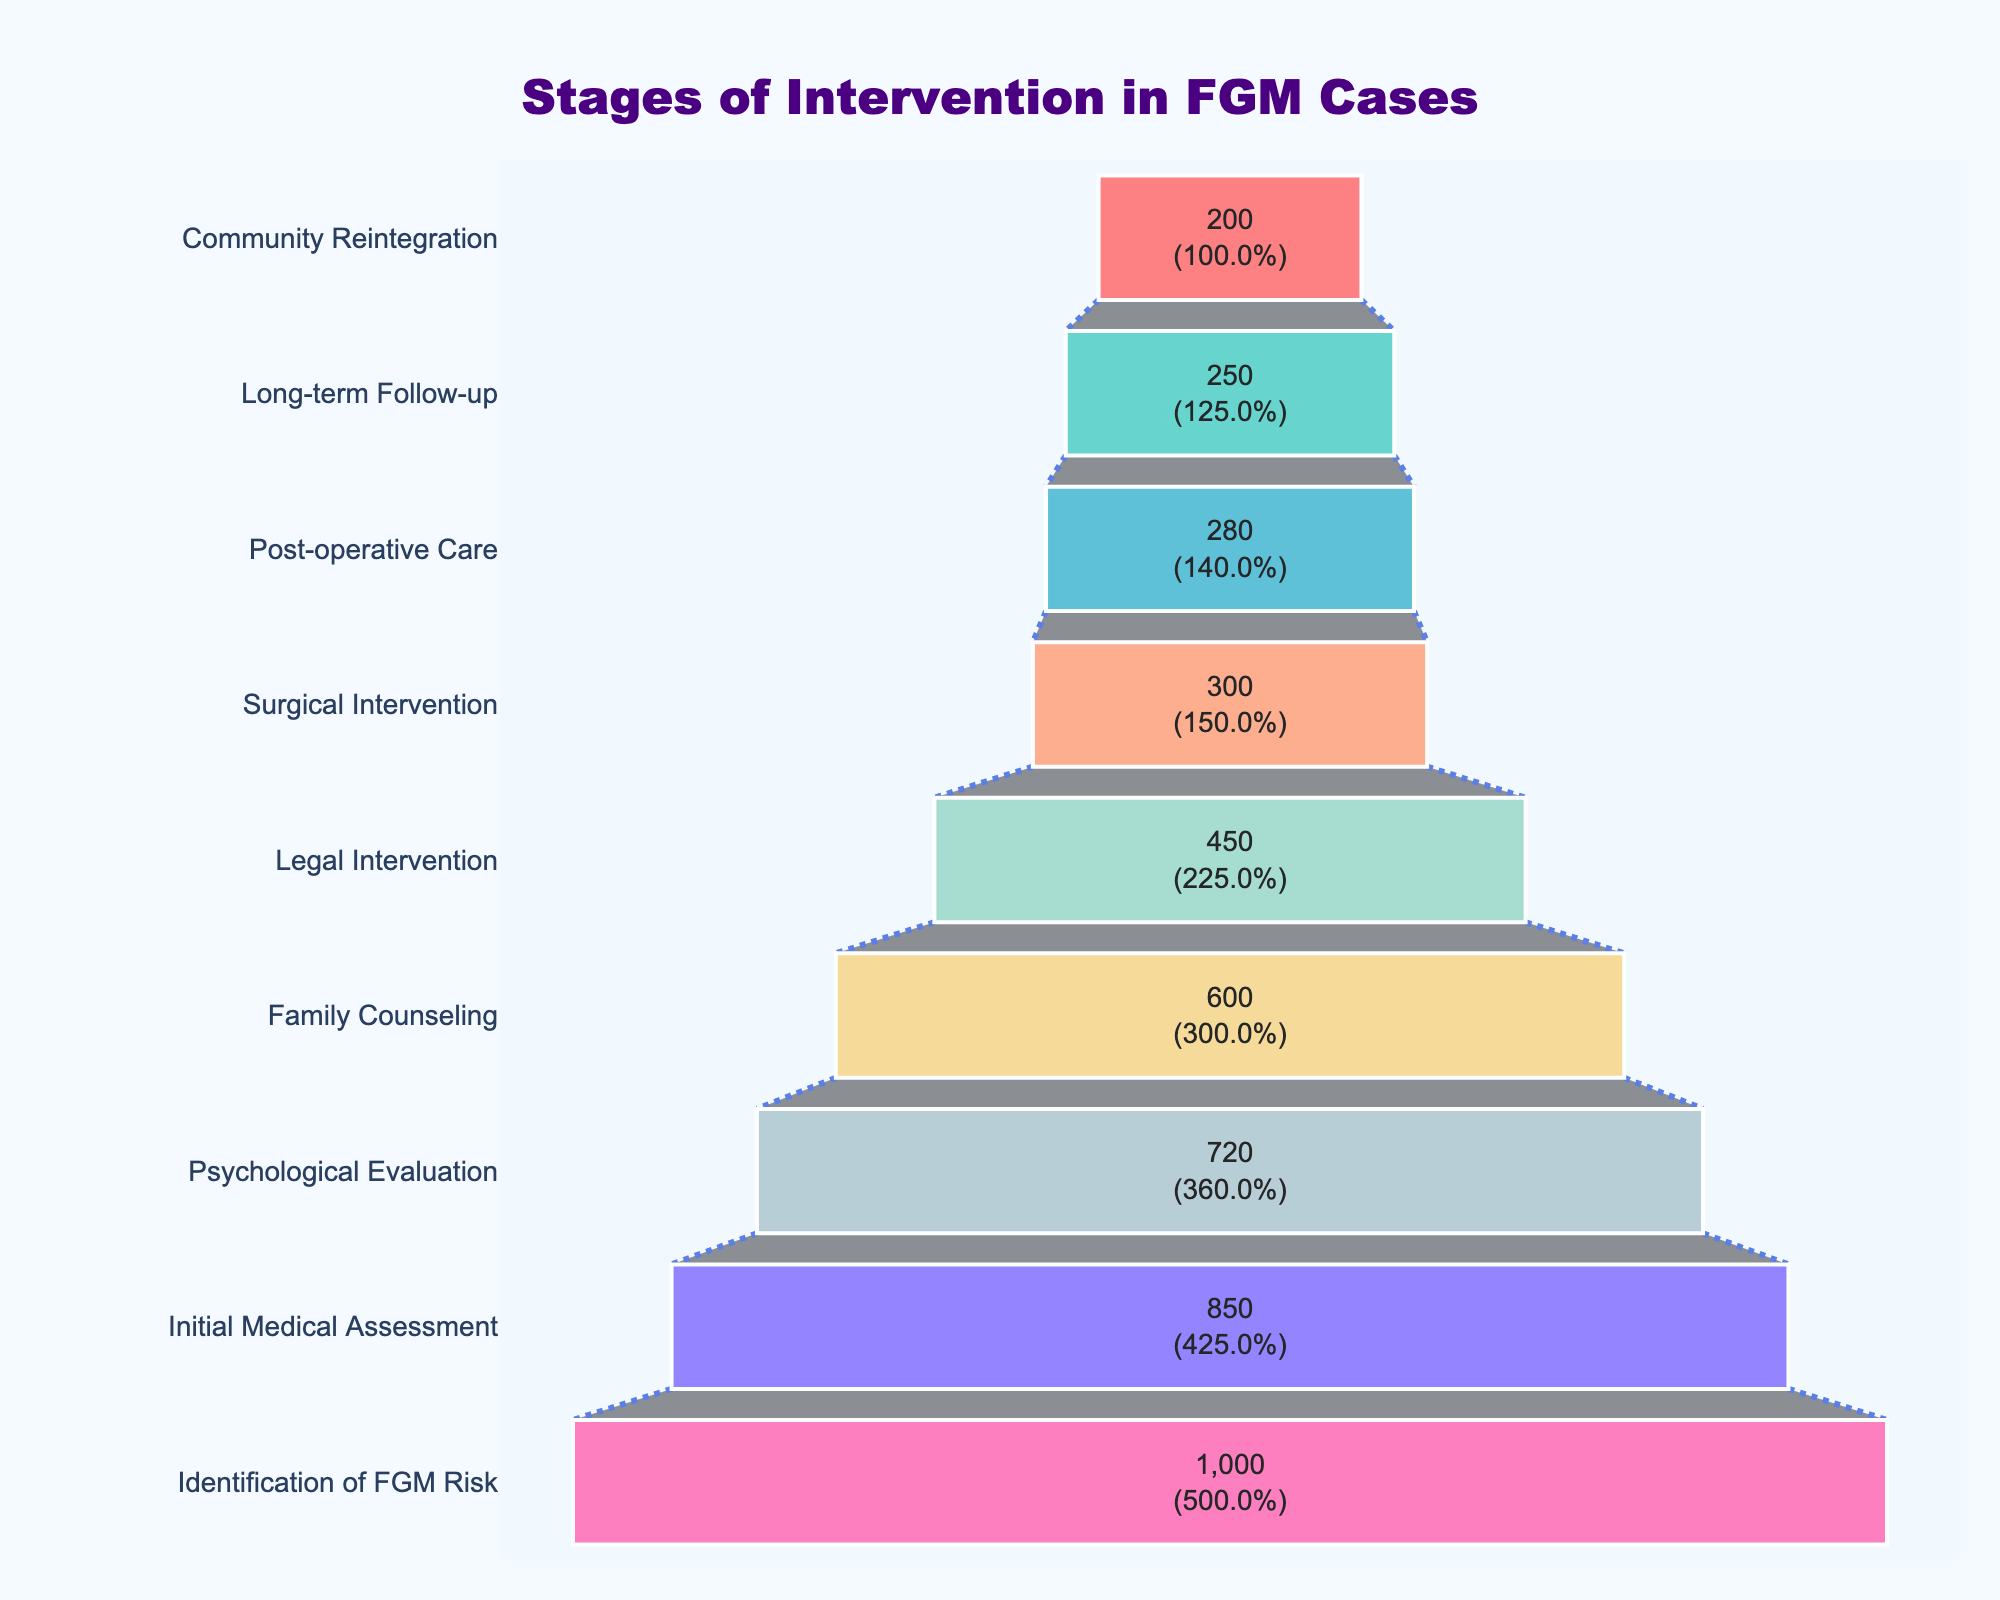How many stages are depicted in the funnel chart? Count the number of unique stages listed from top to bottom.
Answer: 9 What is the title of the funnel chart? Read the title text prominently displayed at the top of the chart.
Answer: Stages of Intervention in FGM Cases Which stage has the lowest number of cases? Identify the stage at the narrowest part of the funnel at the bottom.
Answer: Community Reintegration How many cases reach the Family Counseling stage? Locate "Family Counseling" on the y-axis and read its corresponding value.
Answer: 600 What percentage of cases identified for FGM risk progress to the Legal Intervention stage? Find the number of cases at the Legal Intervention stage (450) and divide by the initial number of cases (1000), then multiply by 100 to get the percentage: (450/1000) * 100.
Answer: 45% How many more cases are there in the Initial Medical Assessment stage than in the Psychological Evaluation stage? Subtract the number of cases in the Psychological Evaluation stage (720) from those in the Initial Medical Assessment stage (850). 850 - 720 = 130.
Answer: 130 What is the drop in the number of cases from Surgical Intervention to Post-operative Care? Subtract the number for Post-operative Care (280) from the number for Surgical Intervention (300). 300 - 280 = 20.
Answer: 20 Which stage shows the highest percentage decrease from the previous stage? Calculate the percentage decrease between subsequent stages and compare. For example, from Identification of FGM Risk to Initial Medical Assessment: (1000 - 850) / 1000 * 100 = 15%. Continue this pattern for each pair. The highest percentage drop is between Initial Medical Assessment (850) and Psychological Evaluation (720): (850 - 720) / 850 * 100 = 15.29%. The next highest is between Family Counseling (600) and Legal Intervention (450): (600 - 450) / 600 * 100 = 25%.
Answer: Family Counseling to Legal Intervention How many cases make it all the way through to Community Reintegration? Look at the number corresponding to Community Reintegration at the bottom of the funnel.
Answer: 200 What is the color used to represent the Psychological Evaluation stage? Observe the bar color corresponding to the Psychological Evaluation stage on the y-axis.
Answer: Light blue In terms of absolute numbers, how much is the combined drop from Identification of FGM Risk to Long-term Follow-up? Sum the absolute drops between each subsequent stage until Long-term Follow-up: 
1. Identification of FGM Risk to Initial Medical Assessment: 1000 - 850 = 150
2. Initial Medical Assessment to Psychological Evaluation: 850 - 720 = 130
3. Psychological Evaluation to Family Counseling: 720 - 600 = 120
4. Family Counseling to Legal Intervention: 600 - 450 = 150
5. Legal Intervention to Surgical Intervention: 450 - 300 = 150
6. Surgical Intervention to Post-operative Care: 300 - 280 = 20
7. Post-operative Care to Long-term Follow-up: 280 - 250 = 30
Total drop: 150 + 130 + 120 + 150 + 150 + 20 + 30 = 750.
Answer: 750 